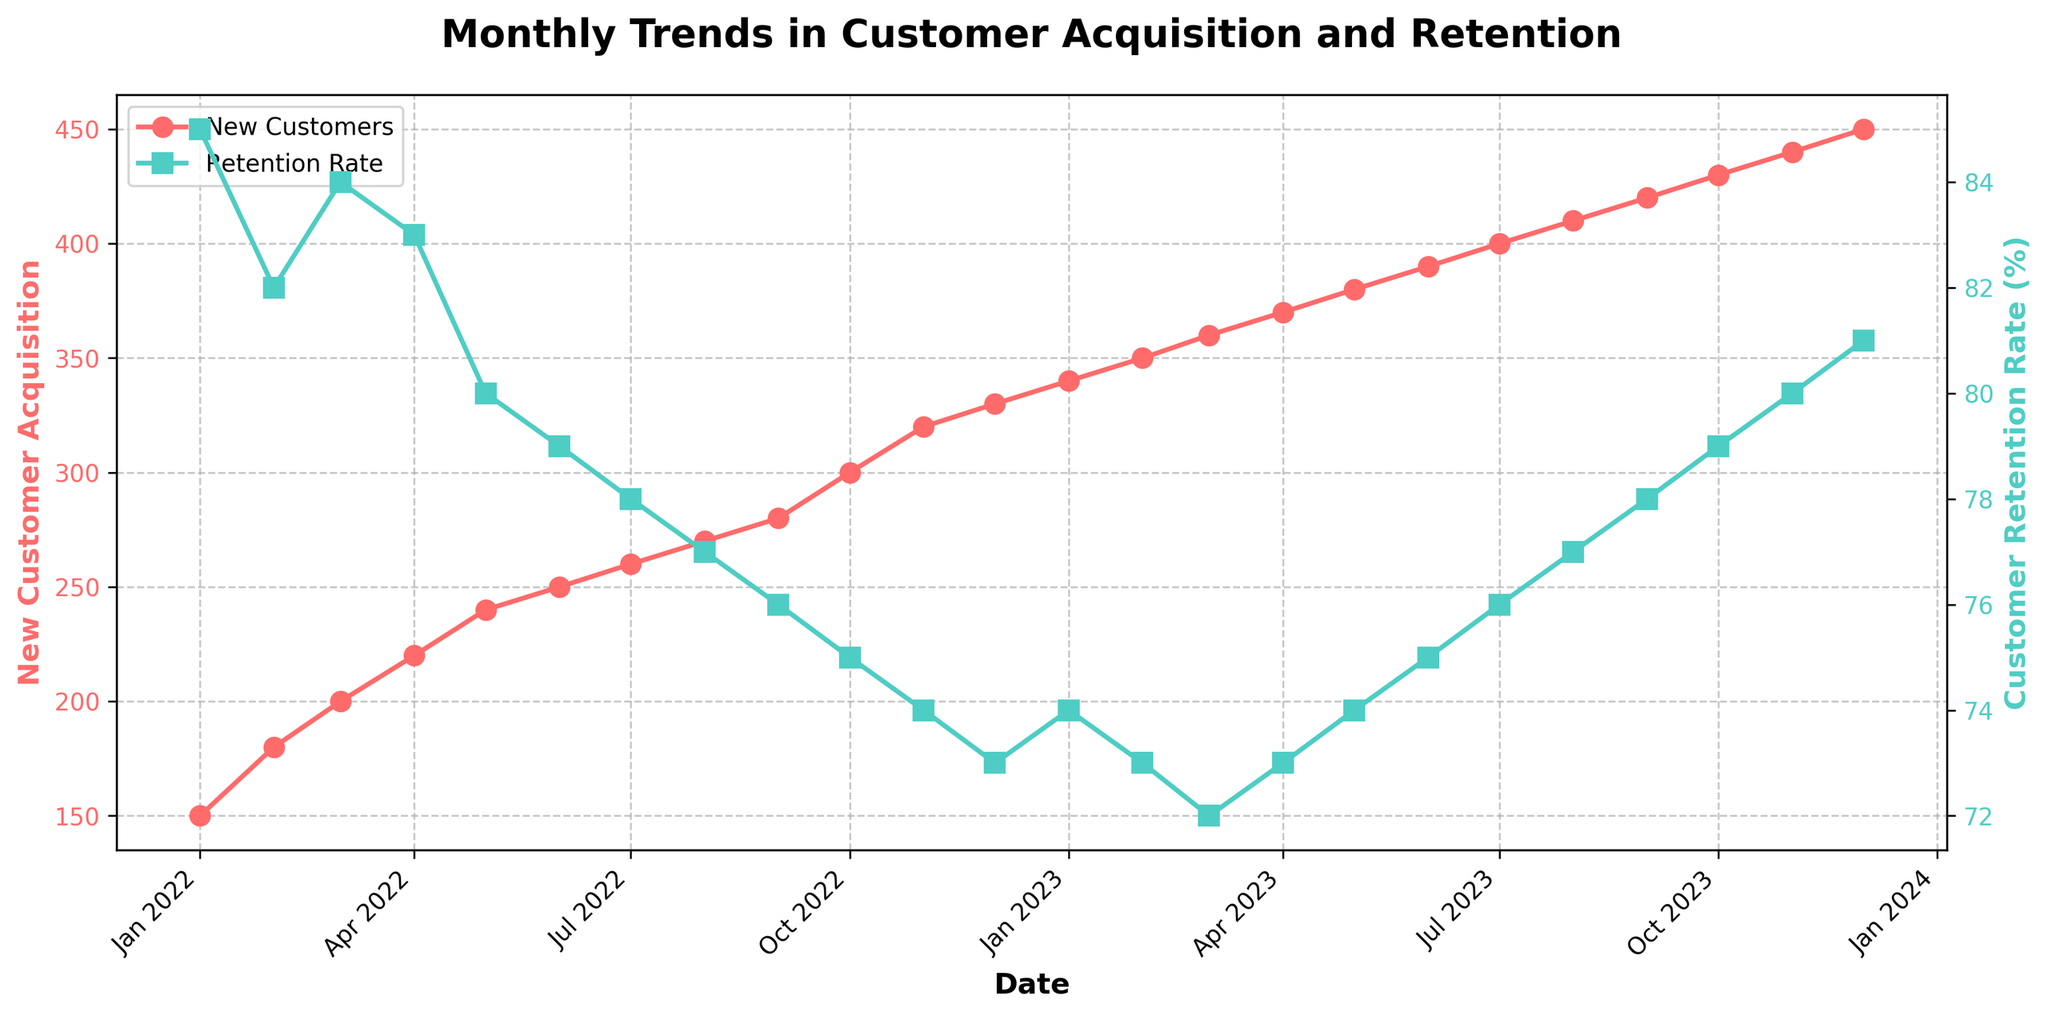What is the title of the figure? The title is usually displayed at the top of the figure. In this case, it reads 'Monthly Trends in Customer Acquisition and Retention'.
Answer: Monthly Trends in Customer Acquisition and Retention What colors are used to represent New Customer Acquisition and Customer Retention Rate? The plot uses different colors to distinguish between the two metrics. New Customer Acquisition is represented by red, and Customer Retention Rate is represented by turquoise.
Answer: Red and turquoise How does the New Customer Acquisition trend change over the past two years? By observing the New Customer Acquisition line over the time period, you can see that it consistently increases from January 2022 to December 2023.
Answer: It increases What was the New Customer Acquisition figure for December 2023? Locate the data point for December 2023 on the x-axis and see where it intersects with the New Customer Acquisition line. The value is 450.
Answer: 450 What is the general trend in the Customer Retention Rate over the past two years? The Customer Retention Rate line shows a decreasing trend from January 2022 to December 2022, and then it starts to gradually increase throughout 2023.
Answer: Decreases then increases What was the lowest Customer Retention Rate, and when did it occur? Find the lowest point on the Customer Retention Rate line and identify the corresponding month and year. The lowest rate of 72% occurred in March 2023.
Answer: 72% in March 2023 How do the New Customer Acquisition and Customer Retention Rate compare in July 2023? For July 2023, locate the data points on both the New Customer Acquisition and Customer Retention Rate lines. New Customer Acquisition was 400, while Customer Retention Rate was 76%.
Answer: 400 for acquisition, 76% for retention What was the increase in New Customer Acquisition from January 2022 to December 2023? Take the New Customer Acquisition values from January 2022 (150) and December 2023 (450) and calculate the difference: 450 - 150 = 300.
Answer: 300 How did the Customer Retention Rate in December 2023 compare to that in January 2022? Check the Customer Retention Rate for January 2022 (85%) and December 2023 (81%). Compare the two values to see that it decreased by 4%.
Answer: Decreased by 4% In which month of 2023 did the Customer Retention Rate first exceed 75%? Observe the Customer Retention Rate line for the year 2023 and find the month where it first exceeds 75%. It first exceeds in June 2023 with a rate of 75%.
Answer: June 2023 